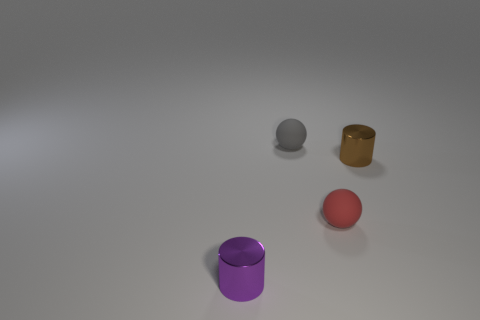There is a object that is on the left side of the red rubber sphere and to the right of the small purple metal thing; how big is it?
Ensure brevity in your answer.  Small. Are there any gray rubber spheres of the same size as the gray thing?
Offer a very short reply. No. Is the number of cylinders that are in front of the tiny purple thing greater than the number of purple shiny things that are right of the gray rubber object?
Your answer should be compact. No. Is the material of the gray object the same as the thing to the left of the gray ball?
Your answer should be very brief. No. What number of tiny gray rubber spheres are on the right side of the tiny metallic cylinder behind the sphere in front of the small brown object?
Give a very brief answer. 0. There is a small gray thing; is it the same shape as the small rubber object that is in front of the small brown shiny object?
Make the answer very short. Yes. There is a thing that is to the left of the red rubber object and behind the tiny purple cylinder; what is its color?
Offer a terse response. Gray. What is the small cylinder behind the small metal cylinder that is on the left side of the metal object that is to the right of the small purple metal cylinder made of?
Your answer should be very brief. Metal. What is the tiny gray thing made of?
Provide a short and direct response. Rubber. What size is the brown shiny object that is the same shape as the small purple shiny object?
Offer a terse response. Small. 